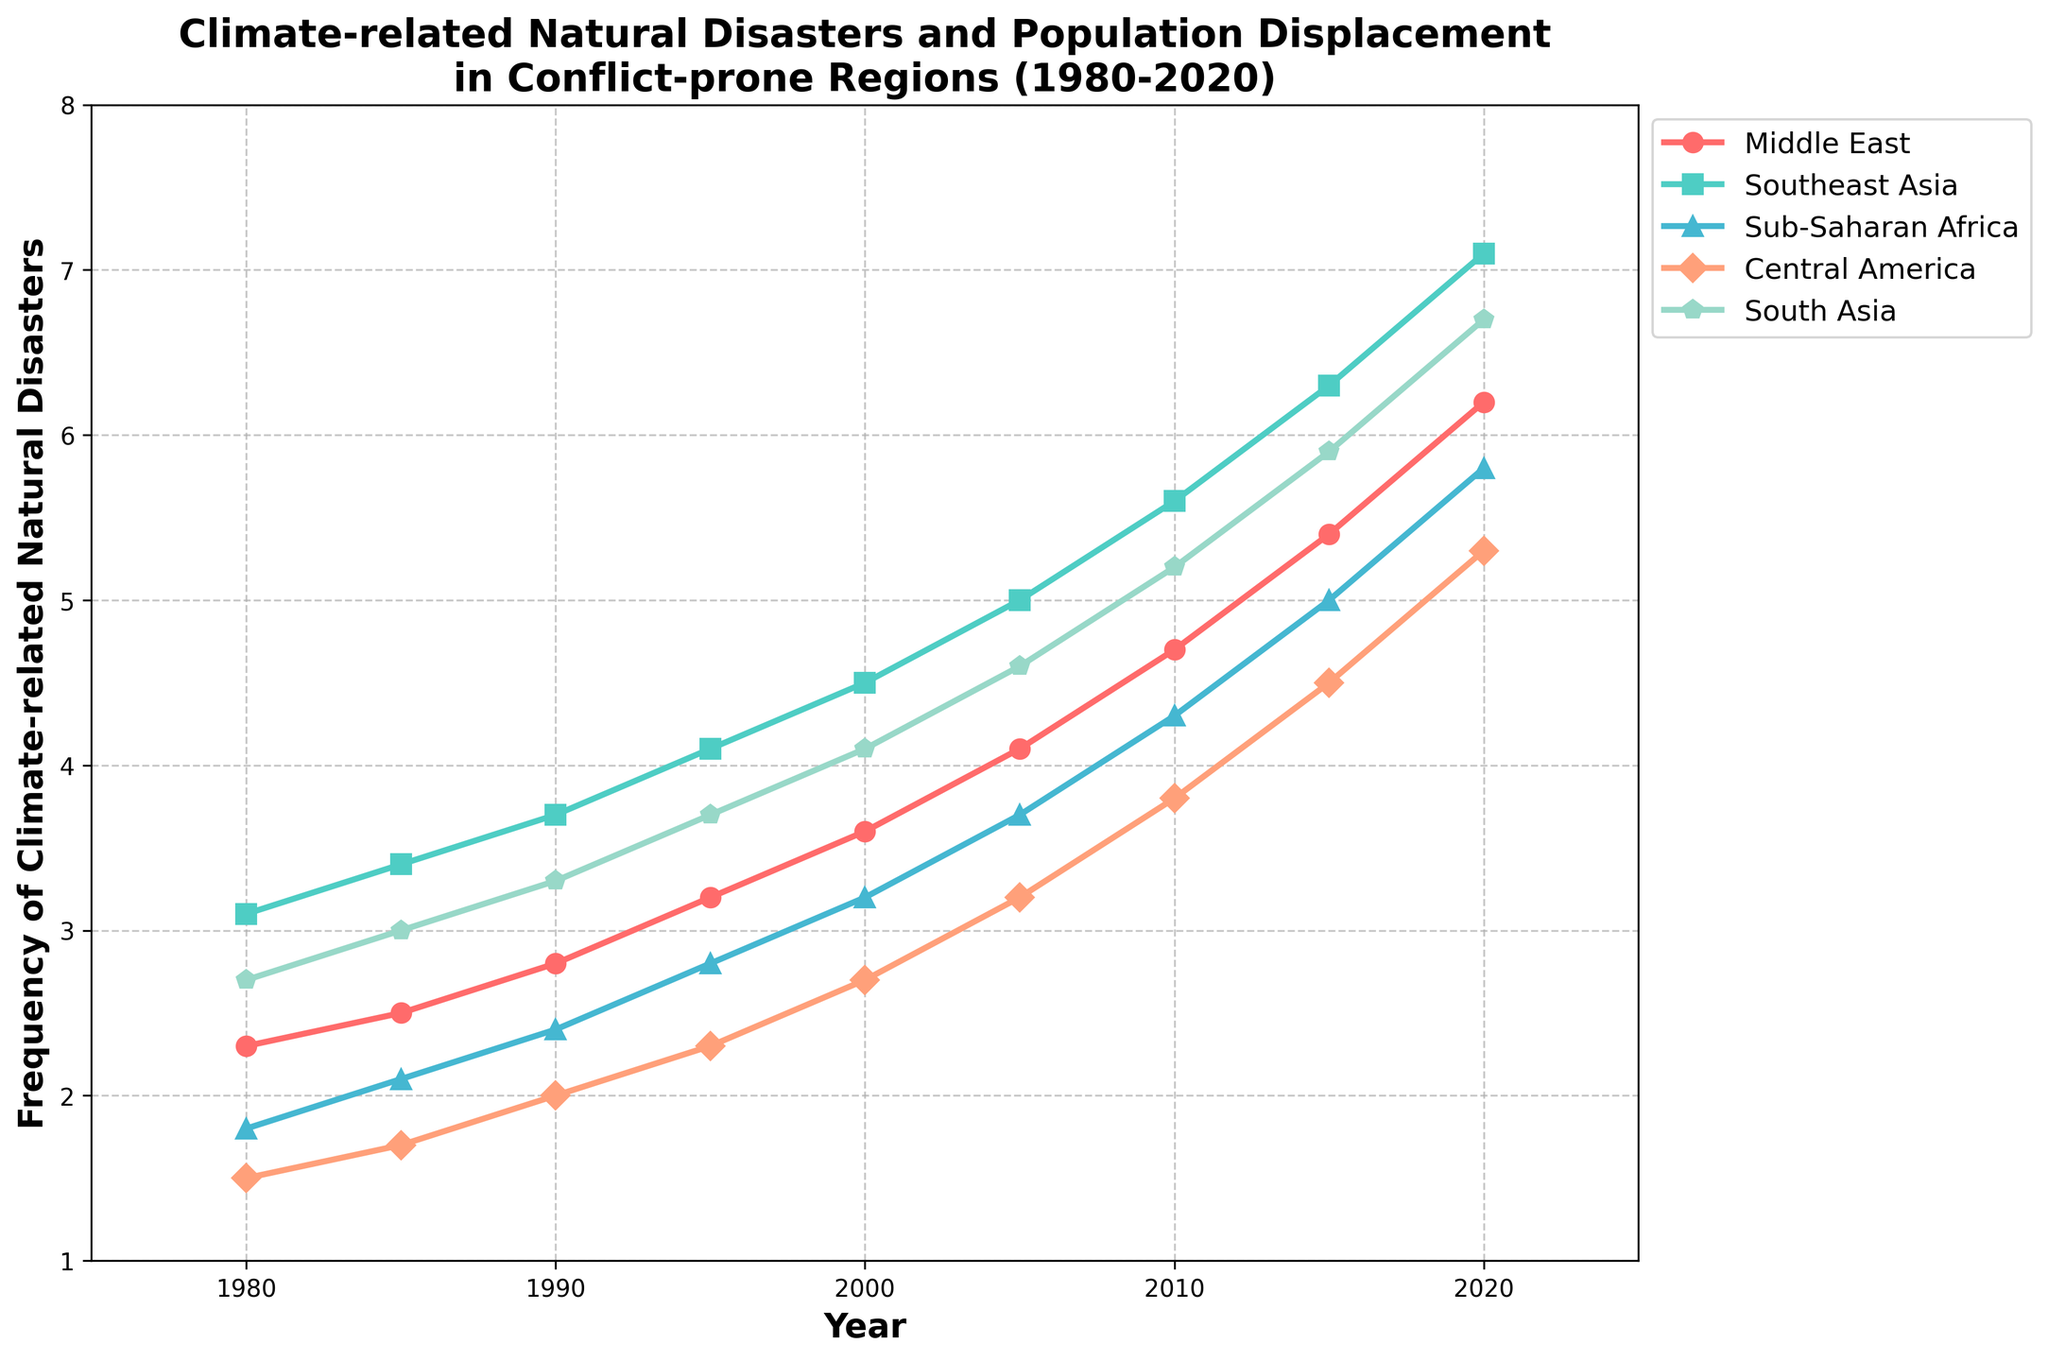What is the general trend for the frequency of climate-related natural disasters in the Middle East from 1980 to 2020? The frequency of climate-related natural disasters in the Middle East shows a consistent upward trend from 1980 to 2020, starting at 2.3 in 1980 and increasing to 6.2 in 2020.
Answer: Increasing trend Which region experienced the highest frequency of climate-related natural disasters in 2020? By looking at the data series for 2020, Southeast Asia experienced the highest frequency at 7.1.
Answer: Southeast Asia Comparing 1990 and 2020, how much did the frequency of climate-related natural disasters increase in Sub-Saharan Africa? The frequency in Sub-Saharan Africa was 2.4 in 1990 and increased to 5.8 in 2020. The increase can be calculated as 5.8 - 2.4 = 3.4.
Answer: 3.4 Which two regions had almost equal frequencies of climate-related natural disasters around the year 2000, and what were those frequencies? Around the year 2000, Central America and Sub-Saharan Africa had nearly equal frequencies, with Central America at 2.7 and Sub-Saharan Africa at 3.2.
Answer: Central America (2.7), Sub-Saharan Africa (3.2) What is the average frequency of climate-related natural disasters in South Asia from 1980 to 2020? Sum the frequencies from the table for South Asia from 1980 to 2020 (2.7, 3.0, 3.3, 3.7, 4.1, 4.6, 5.2, 5.9, 6.7) and divide by the number of data points (9). (2.7+3.0+3.3+3.7+4.1+4.6+5.2+5.9+6.7)/9 = 4.24.
Answer: 4.24 Between 1980 and 2010, which region shows the greatest increase in the frequency of climate-related natural disasters? Calculate the differences for each region from 1980 to 2010: Middle East (4.7-2.3=2.4), Southeast Asia (5.6-3.1=2.5), Sub-Saharan Africa (4.3-1.8=2.5), Central America (3.8-1.5=2.3), South Asia (5.2-2.7=2.5). The regions Southeast Asia, Sub-Saharan Africa, and South Asia all show the greatest increase, each at 2.5.
Answer: Southeast Asia, Sub-Saharan Africa, South Asia In 2015, which region had the lowest frequency of climate-related natural disasters and what was it? By referring to the data for 2015, Central America had the lowest frequency at 4.5.
Answer: Central America Which region shows the steepest increase in the frequency of climate-related natural disasters between 2000 and 2020? Calculate the differences in frequency from 2000 to 2020: Middle East (6.2-3.6=2.6), Southeast Asia (7.1-4.5=2.6), Sub-Saharan Africa (5.8-3.2=2.6), Central America (5.3-2.7=2.6), South Asia (6.7-4.1=2.6). All regions show a uniform increase of 2.6, indicating a steep rise.
Answer: All regions (2.6) What is the range of frequencies observed for Central America over the years? To determine the range, subtract the smallest frequency observed (1.5 in 1980) from the largest frequency observed (5.3 in 2020) for Central America. 5.3 - 1.5 = 3.8.
Answer: 3.8 In which decade did South Asia experience the most significant increase in the frequency of climate-related natural disasters? Observe the change in frequencies across each decade: 1980-1990 (3.3-2.7=0.6), 1990-2000 (4.1-3.3=0.8), 2000-2010 (5.2-4.1=1.1), 2010-2020 (6.7-5.2=1.5). The largest increase is between 2010 and 2020, which is 1.5.
Answer: 2010-2020 